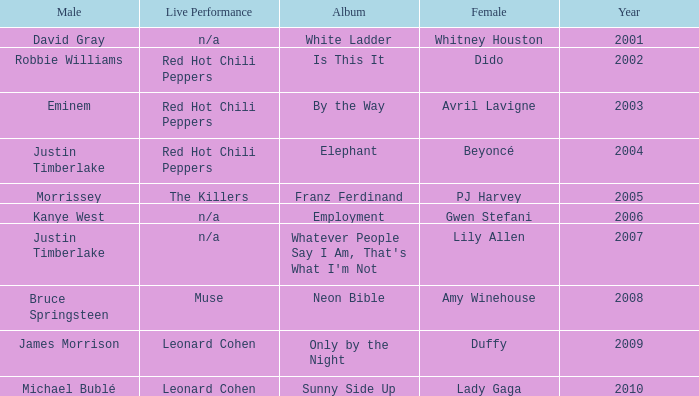Who is the male partner for amy winehouse? Bruce Springsteen. 